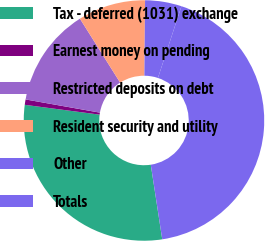Convert chart to OTSL. <chart><loc_0><loc_0><loc_500><loc_500><pie_chart><fcel>Tax - deferred (1031) exchange<fcel>Earnest money on pending<fcel>Restricted deposits on debt<fcel>Resident security and utility<fcel>Other<fcel>Totals<nl><fcel>29.5%<fcel>0.72%<fcel>13.26%<fcel>9.08%<fcel>4.9%<fcel>42.52%<nl></chart> 